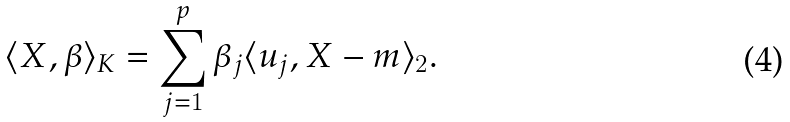<formula> <loc_0><loc_0><loc_500><loc_500>\langle X , \beta \rangle _ { K } = \sum _ { j = 1 } ^ { p } \beta _ { j } \langle u _ { j } , X - m \rangle _ { 2 } .</formula> 